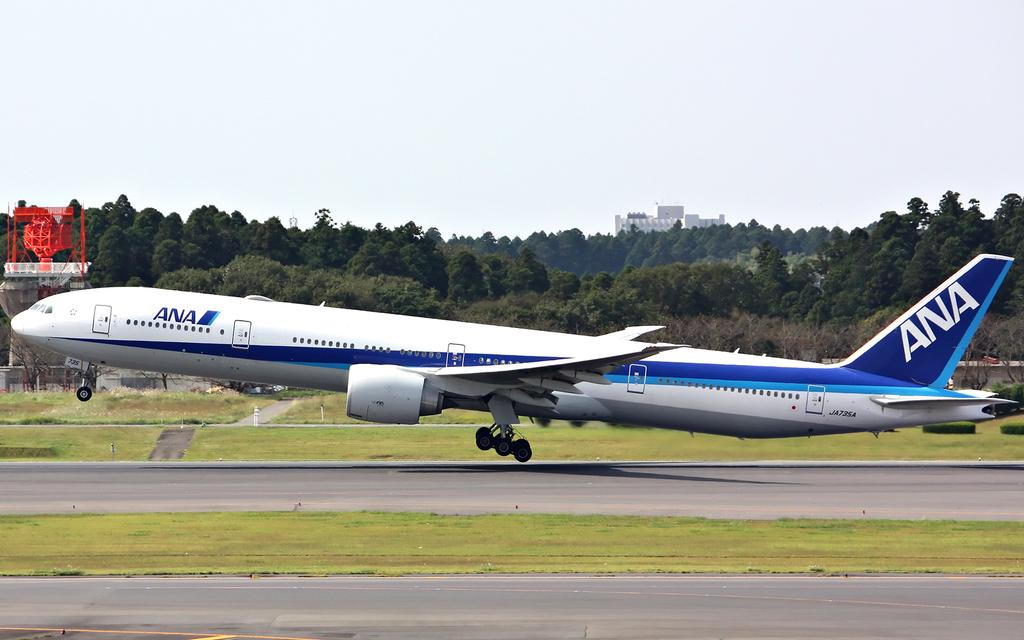<image>
Describe the image concisely. a plane beginning to take off with ANA on the tail 